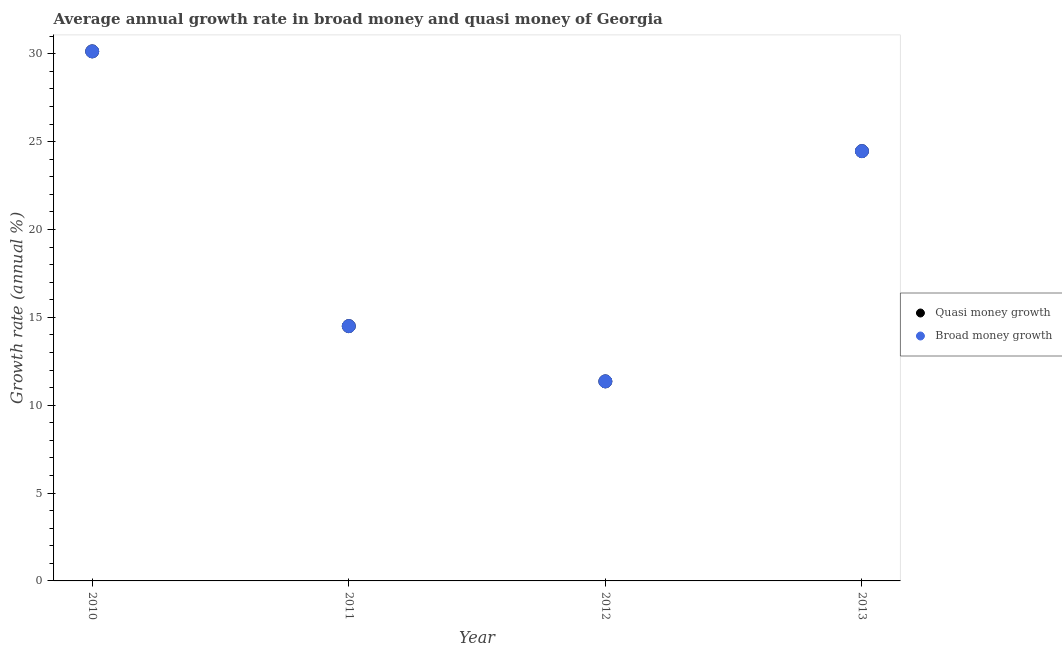How many different coloured dotlines are there?
Provide a short and direct response. 2. Is the number of dotlines equal to the number of legend labels?
Offer a very short reply. Yes. What is the annual growth rate in broad money in 2010?
Offer a terse response. 30.13. Across all years, what is the maximum annual growth rate in broad money?
Your response must be concise. 30.13. Across all years, what is the minimum annual growth rate in quasi money?
Your response must be concise. 11.36. In which year was the annual growth rate in quasi money minimum?
Offer a terse response. 2012. What is the total annual growth rate in broad money in the graph?
Offer a terse response. 80.44. What is the difference between the annual growth rate in quasi money in 2011 and that in 2012?
Ensure brevity in your answer.  3.14. What is the difference between the annual growth rate in quasi money in 2011 and the annual growth rate in broad money in 2010?
Give a very brief answer. -15.63. What is the average annual growth rate in broad money per year?
Make the answer very short. 20.11. What is the ratio of the annual growth rate in broad money in 2010 to that in 2011?
Keep it short and to the point. 2.08. What is the difference between the highest and the second highest annual growth rate in broad money?
Provide a short and direct response. 5.68. What is the difference between the highest and the lowest annual growth rate in quasi money?
Give a very brief answer. 18.78. In how many years, is the annual growth rate in broad money greater than the average annual growth rate in broad money taken over all years?
Keep it short and to the point. 2. Is the annual growth rate in quasi money strictly less than the annual growth rate in broad money over the years?
Your answer should be very brief. No. How many dotlines are there?
Ensure brevity in your answer.  2. Are the values on the major ticks of Y-axis written in scientific E-notation?
Provide a succinct answer. No. Does the graph contain any zero values?
Provide a succinct answer. No. Does the graph contain grids?
Your response must be concise. No. What is the title of the graph?
Offer a terse response. Average annual growth rate in broad money and quasi money of Georgia. What is the label or title of the X-axis?
Give a very brief answer. Year. What is the label or title of the Y-axis?
Keep it short and to the point. Growth rate (annual %). What is the Growth rate (annual %) of Quasi money growth in 2010?
Give a very brief answer. 30.13. What is the Growth rate (annual %) in Broad money growth in 2010?
Your answer should be very brief. 30.13. What is the Growth rate (annual %) of Quasi money growth in 2011?
Your answer should be compact. 14.5. What is the Growth rate (annual %) of Broad money growth in 2011?
Give a very brief answer. 14.5. What is the Growth rate (annual %) in Quasi money growth in 2012?
Keep it short and to the point. 11.36. What is the Growth rate (annual %) of Broad money growth in 2012?
Ensure brevity in your answer.  11.36. What is the Growth rate (annual %) in Quasi money growth in 2013?
Your answer should be compact. 24.46. What is the Growth rate (annual %) of Broad money growth in 2013?
Offer a very short reply. 24.46. Across all years, what is the maximum Growth rate (annual %) of Quasi money growth?
Make the answer very short. 30.13. Across all years, what is the maximum Growth rate (annual %) of Broad money growth?
Ensure brevity in your answer.  30.13. Across all years, what is the minimum Growth rate (annual %) in Quasi money growth?
Offer a very short reply. 11.36. Across all years, what is the minimum Growth rate (annual %) of Broad money growth?
Offer a terse response. 11.36. What is the total Growth rate (annual %) in Quasi money growth in the graph?
Provide a succinct answer. 80.44. What is the total Growth rate (annual %) of Broad money growth in the graph?
Your answer should be very brief. 80.44. What is the difference between the Growth rate (annual %) in Quasi money growth in 2010 and that in 2011?
Your answer should be compact. 15.63. What is the difference between the Growth rate (annual %) of Broad money growth in 2010 and that in 2011?
Ensure brevity in your answer.  15.63. What is the difference between the Growth rate (annual %) of Quasi money growth in 2010 and that in 2012?
Ensure brevity in your answer.  18.78. What is the difference between the Growth rate (annual %) of Broad money growth in 2010 and that in 2012?
Ensure brevity in your answer.  18.78. What is the difference between the Growth rate (annual %) of Quasi money growth in 2010 and that in 2013?
Your answer should be compact. 5.68. What is the difference between the Growth rate (annual %) in Broad money growth in 2010 and that in 2013?
Your response must be concise. 5.68. What is the difference between the Growth rate (annual %) of Quasi money growth in 2011 and that in 2012?
Keep it short and to the point. 3.14. What is the difference between the Growth rate (annual %) of Broad money growth in 2011 and that in 2012?
Make the answer very short. 3.14. What is the difference between the Growth rate (annual %) in Quasi money growth in 2011 and that in 2013?
Provide a succinct answer. -9.96. What is the difference between the Growth rate (annual %) of Broad money growth in 2011 and that in 2013?
Give a very brief answer. -9.96. What is the difference between the Growth rate (annual %) in Quasi money growth in 2012 and that in 2013?
Your response must be concise. -13.1. What is the difference between the Growth rate (annual %) in Broad money growth in 2012 and that in 2013?
Your response must be concise. -13.1. What is the difference between the Growth rate (annual %) of Quasi money growth in 2010 and the Growth rate (annual %) of Broad money growth in 2011?
Make the answer very short. 15.63. What is the difference between the Growth rate (annual %) of Quasi money growth in 2010 and the Growth rate (annual %) of Broad money growth in 2012?
Ensure brevity in your answer.  18.78. What is the difference between the Growth rate (annual %) of Quasi money growth in 2010 and the Growth rate (annual %) of Broad money growth in 2013?
Provide a short and direct response. 5.68. What is the difference between the Growth rate (annual %) in Quasi money growth in 2011 and the Growth rate (annual %) in Broad money growth in 2012?
Offer a terse response. 3.14. What is the difference between the Growth rate (annual %) in Quasi money growth in 2011 and the Growth rate (annual %) in Broad money growth in 2013?
Provide a succinct answer. -9.96. What is the difference between the Growth rate (annual %) of Quasi money growth in 2012 and the Growth rate (annual %) of Broad money growth in 2013?
Give a very brief answer. -13.1. What is the average Growth rate (annual %) of Quasi money growth per year?
Offer a very short reply. 20.11. What is the average Growth rate (annual %) in Broad money growth per year?
Your response must be concise. 20.11. In the year 2012, what is the difference between the Growth rate (annual %) in Quasi money growth and Growth rate (annual %) in Broad money growth?
Keep it short and to the point. 0. In the year 2013, what is the difference between the Growth rate (annual %) in Quasi money growth and Growth rate (annual %) in Broad money growth?
Make the answer very short. 0. What is the ratio of the Growth rate (annual %) of Quasi money growth in 2010 to that in 2011?
Keep it short and to the point. 2.08. What is the ratio of the Growth rate (annual %) of Broad money growth in 2010 to that in 2011?
Your answer should be compact. 2.08. What is the ratio of the Growth rate (annual %) in Quasi money growth in 2010 to that in 2012?
Make the answer very short. 2.65. What is the ratio of the Growth rate (annual %) in Broad money growth in 2010 to that in 2012?
Your response must be concise. 2.65. What is the ratio of the Growth rate (annual %) of Quasi money growth in 2010 to that in 2013?
Provide a short and direct response. 1.23. What is the ratio of the Growth rate (annual %) of Broad money growth in 2010 to that in 2013?
Offer a terse response. 1.23. What is the ratio of the Growth rate (annual %) of Quasi money growth in 2011 to that in 2012?
Provide a short and direct response. 1.28. What is the ratio of the Growth rate (annual %) of Broad money growth in 2011 to that in 2012?
Give a very brief answer. 1.28. What is the ratio of the Growth rate (annual %) of Quasi money growth in 2011 to that in 2013?
Offer a terse response. 0.59. What is the ratio of the Growth rate (annual %) of Broad money growth in 2011 to that in 2013?
Your response must be concise. 0.59. What is the ratio of the Growth rate (annual %) in Quasi money growth in 2012 to that in 2013?
Your answer should be compact. 0.46. What is the ratio of the Growth rate (annual %) in Broad money growth in 2012 to that in 2013?
Make the answer very short. 0.46. What is the difference between the highest and the second highest Growth rate (annual %) in Quasi money growth?
Offer a terse response. 5.68. What is the difference between the highest and the second highest Growth rate (annual %) of Broad money growth?
Your response must be concise. 5.68. What is the difference between the highest and the lowest Growth rate (annual %) of Quasi money growth?
Your answer should be compact. 18.78. What is the difference between the highest and the lowest Growth rate (annual %) of Broad money growth?
Ensure brevity in your answer.  18.78. 